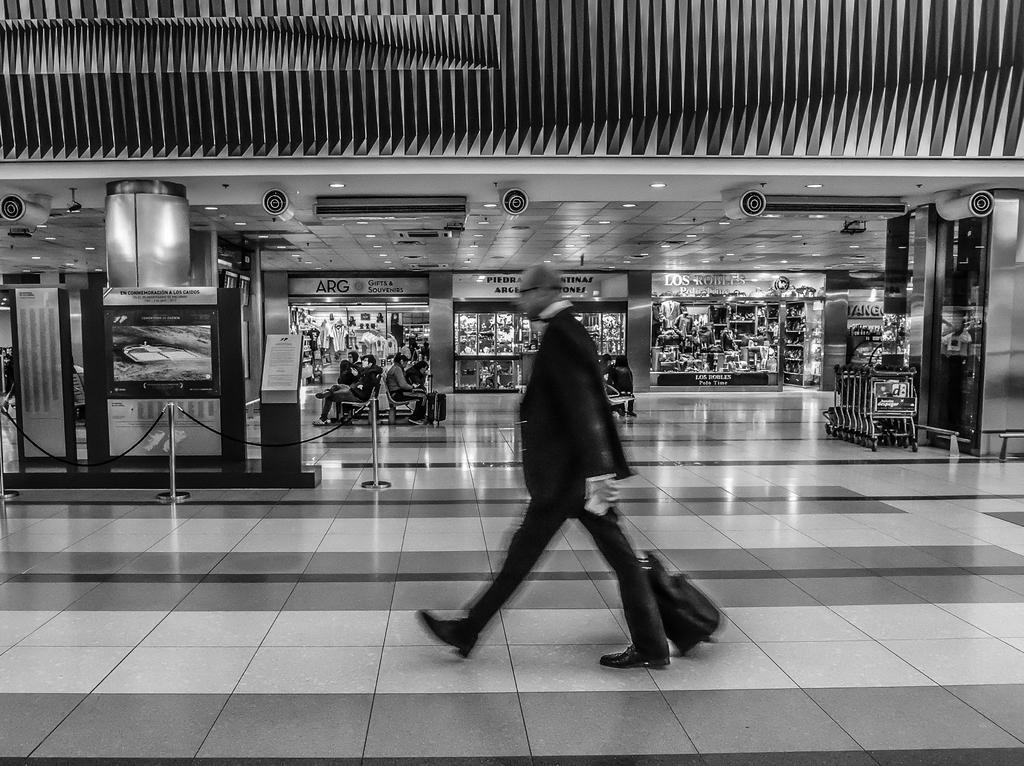Describe this image in one or two sentences. In this image we can see a black and white image. In this image we can see a person, bag and other objects. In the background of the image there are some persons, name boards, ceiling, lights and other objects. At the top of the image there is the wall. At the bottom of the image there is the floor. 